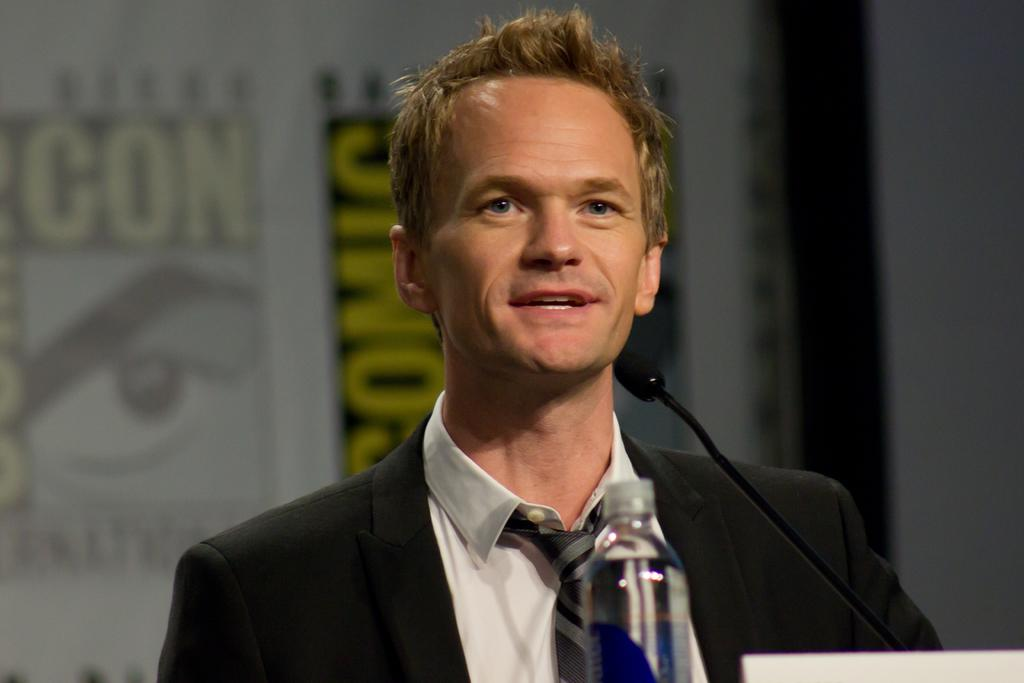What is the main subject of the picture? The main subject of the picture is a man. What is the man doing in the picture? The man is standing and speaking in the picture. What object does the man have to aid in his speaking? The man has a microphone in the picture. What item is placed in front of the man? There is a water bottle in front of the man. What type of farming equipment can be seen in the background of the image? There is no farming equipment visible in the image; it features a man with a microphone and a water bottle. What type of books can be seen on the shelves in the library setting of the image? There is no library setting or bookshelves present in the image. 